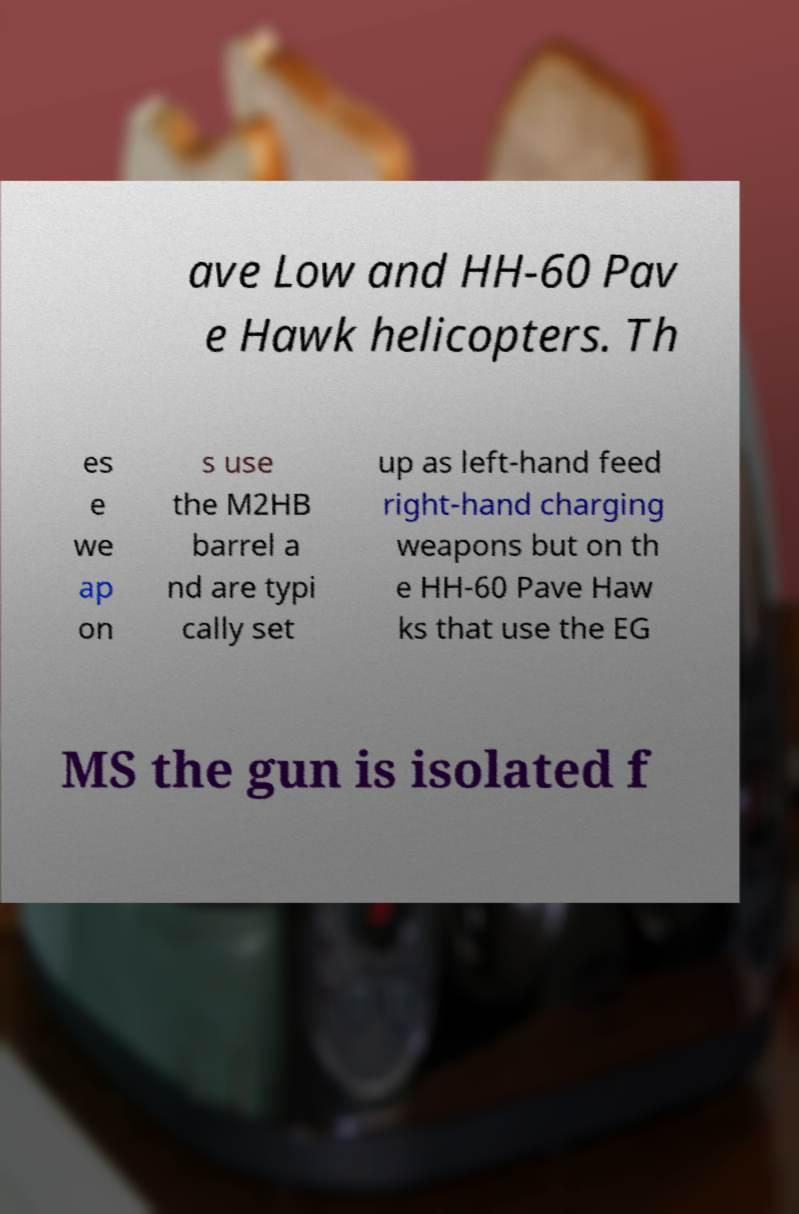Please identify and transcribe the text found in this image. ave Low and HH-60 Pav e Hawk helicopters. Th es e we ap on s use the M2HB barrel a nd are typi cally set up as left-hand feed right-hand charging weapons but on th e HH-60 Pave Haw ks that use the EG MS the gun is isolated f 